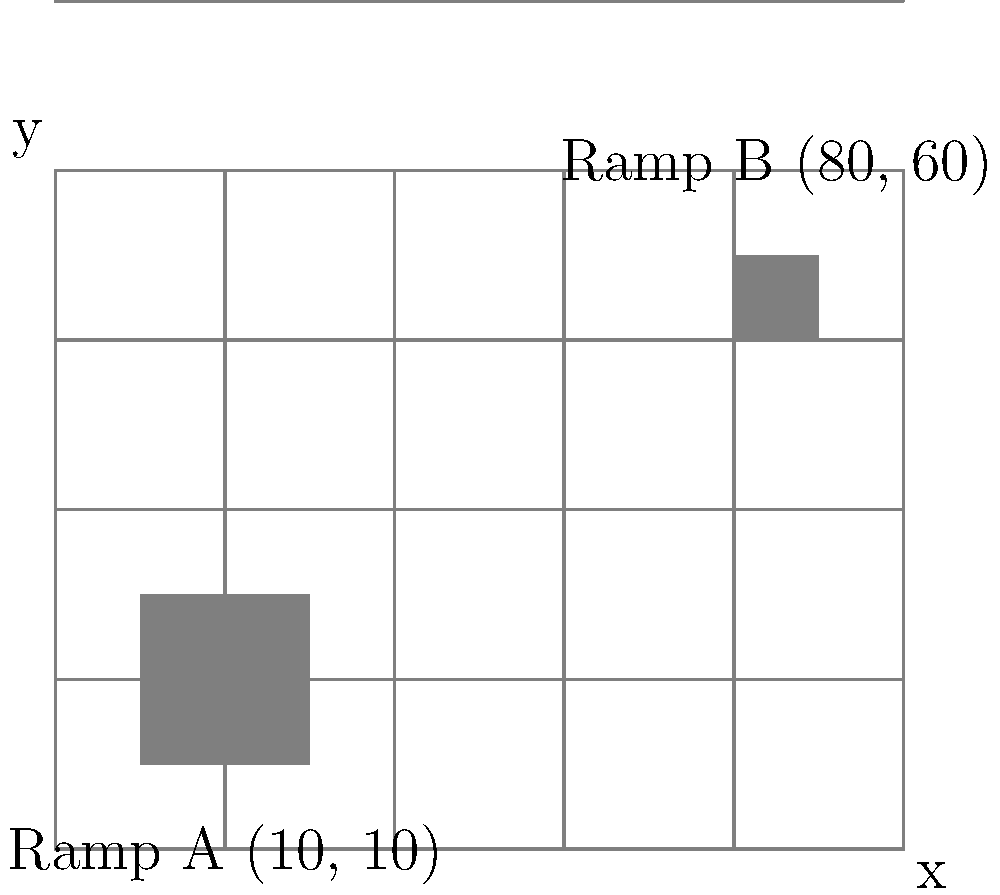At your local skate park in St. Clair, you're curious about the distance between two popular ramps. The park's layout can be represented on a coordinate grid where each unit equals 1 meter. Ramp A is located at coordinates (10, 10), and Ramp B is at (80, 60). Using the distance formula, calculate the straight-line distance between these two ramps to the nearest meter. Let's solve this step-by-step using the distance formula:

1) The distance formula is:
   $$d = \sqrt{(x_2-x_1)^2 + (y_2-y_1)^2}$$

2) We have:
   Ramp A: $(x_1, y_1) = (10, 10)$
   Ramp B: $(x_2, y_2) = (80, 60)$

3) Let's substitute these into the formula:
   $$d = \sqrt{(80-10)^2 + (60-10)^2}$$

4) Simplify inside the parentheses:
   $$d = \sqrt{70^2 + 50^2}$$

5) Calculate the squares:
   $$d = \sqrt{4900 + 2500}$$

6) Add inside the square root:
   $$d = \sqrt{7400}$$

7) Calculate the square root:
   $$d \approx 86.02$$

8) Rounding to the nearest meter:
   $$d \approx 86 \text{ meters}$$
Answer: 86 meters 